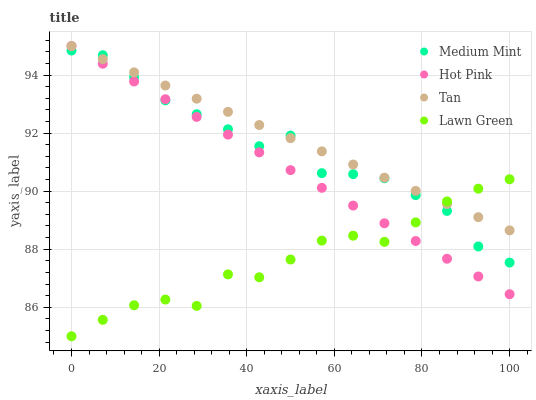Does Lawn Green have the minimum area under the curve?
Answer yes or no. Yes. Does Tan have the maximum area under the curve?
Answer yes or no. Yes. Does Tan have the minimum area under the curve?
Answer yes or no. No. Does Lawn Green have the maximum area under the curve?
Answer yes or no. No. Is Tan the smoothest?
Answer yes or no. Yes. Is Medium Mint the roughest?
Answer yes or no. Yes. Is Lawn Green the smoothest?
Answer yes or no. No. Is Lawn Green the roughest?
Answer yes or no. No. Does Lawn Green have the lowest value?
Answer yes or no. Yes. Does Tan have the lowest value?
Answer yes or no. No. Does Hot Pink have the highest value?
Answer yes or no. Yes. Does Lawn Green have the highest value?
Answer yes or no. No. Does Hot Pink intersect Lawn Green?
Answer yes or no. Yes. Is Hot Pink less than Lawn Green?
Answer yes or no. No. Is Hot Pink greater than Lawn Green?
Answer yes or no. No. 